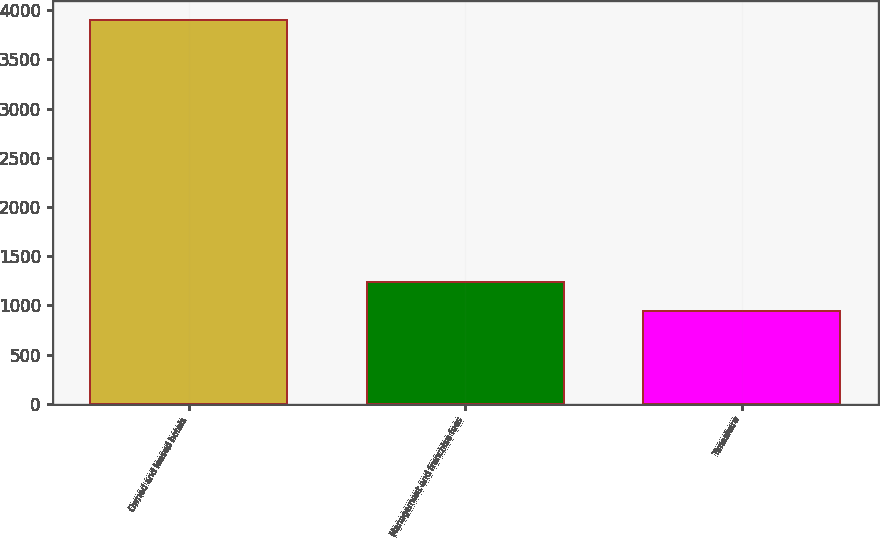Convert chart. <chart><loc_0><loc_0><loc_500><loc_500><bar_chart><fcel>Owned and leased hotels<fcel>Management and franchise fees<fcel>Timeshare<nl><fcel>3898<fcel>1239.4<fcel>944<nl></chart> 